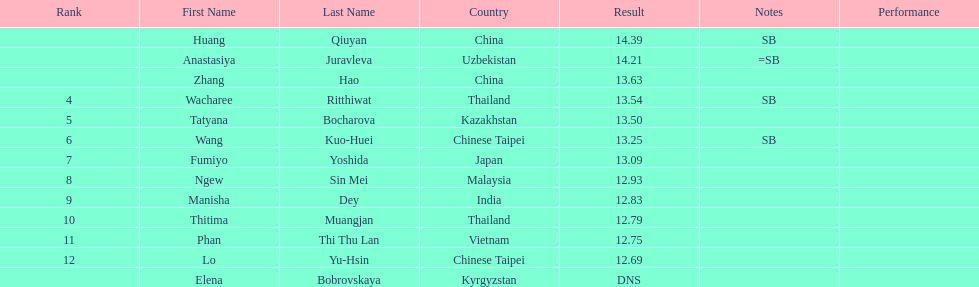What nationality was the woman who won first place? China. 